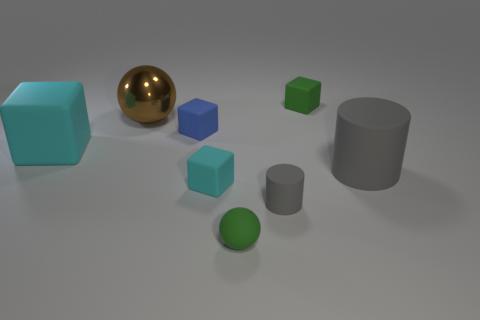Add 1 large rubber blocks. How many objects exist? 9 Subtract all cylinders. How many objects are left? 6 Subtract 0 blue balls. How many objects are left? 8 Subtract all tiny red blocks. Subtract all large matte objects. How many objects are left? 6 Add 6 big objects. How many big objects are left? 9 Add 2 brown spheres. How many brown spheres exist? 3 